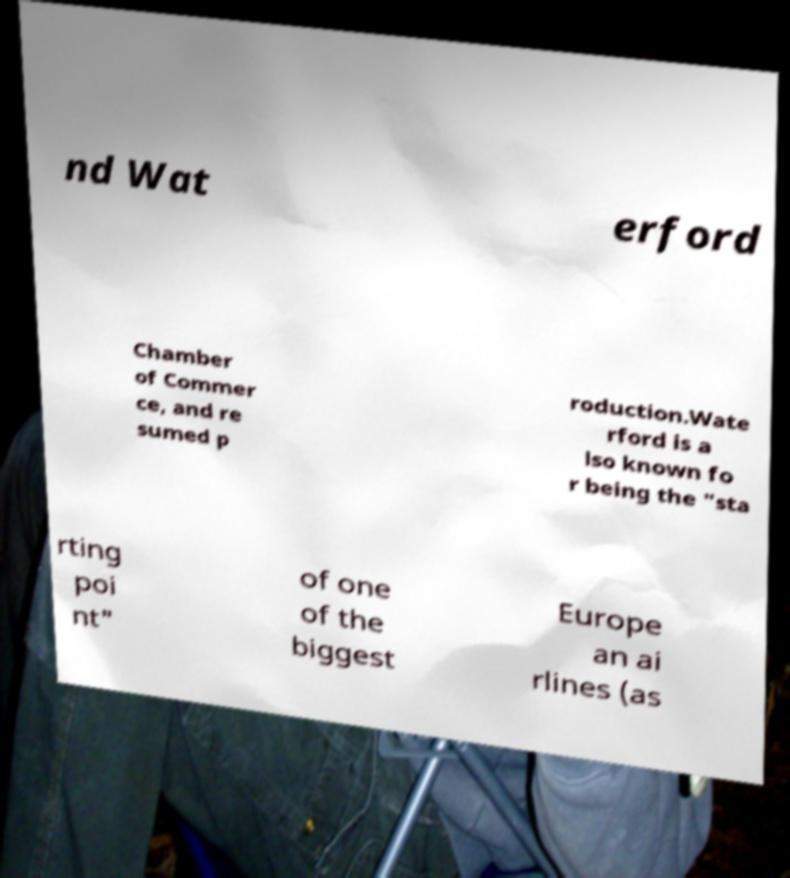Please read and relay the text visible in this image. What does it say? nd Wat erford Chamber of Commer ce, and re sumed p roduction.Wate rford is a lso known fo r being the "sta rting poi nt" of one of the biggest Europe an ai rlines (as 